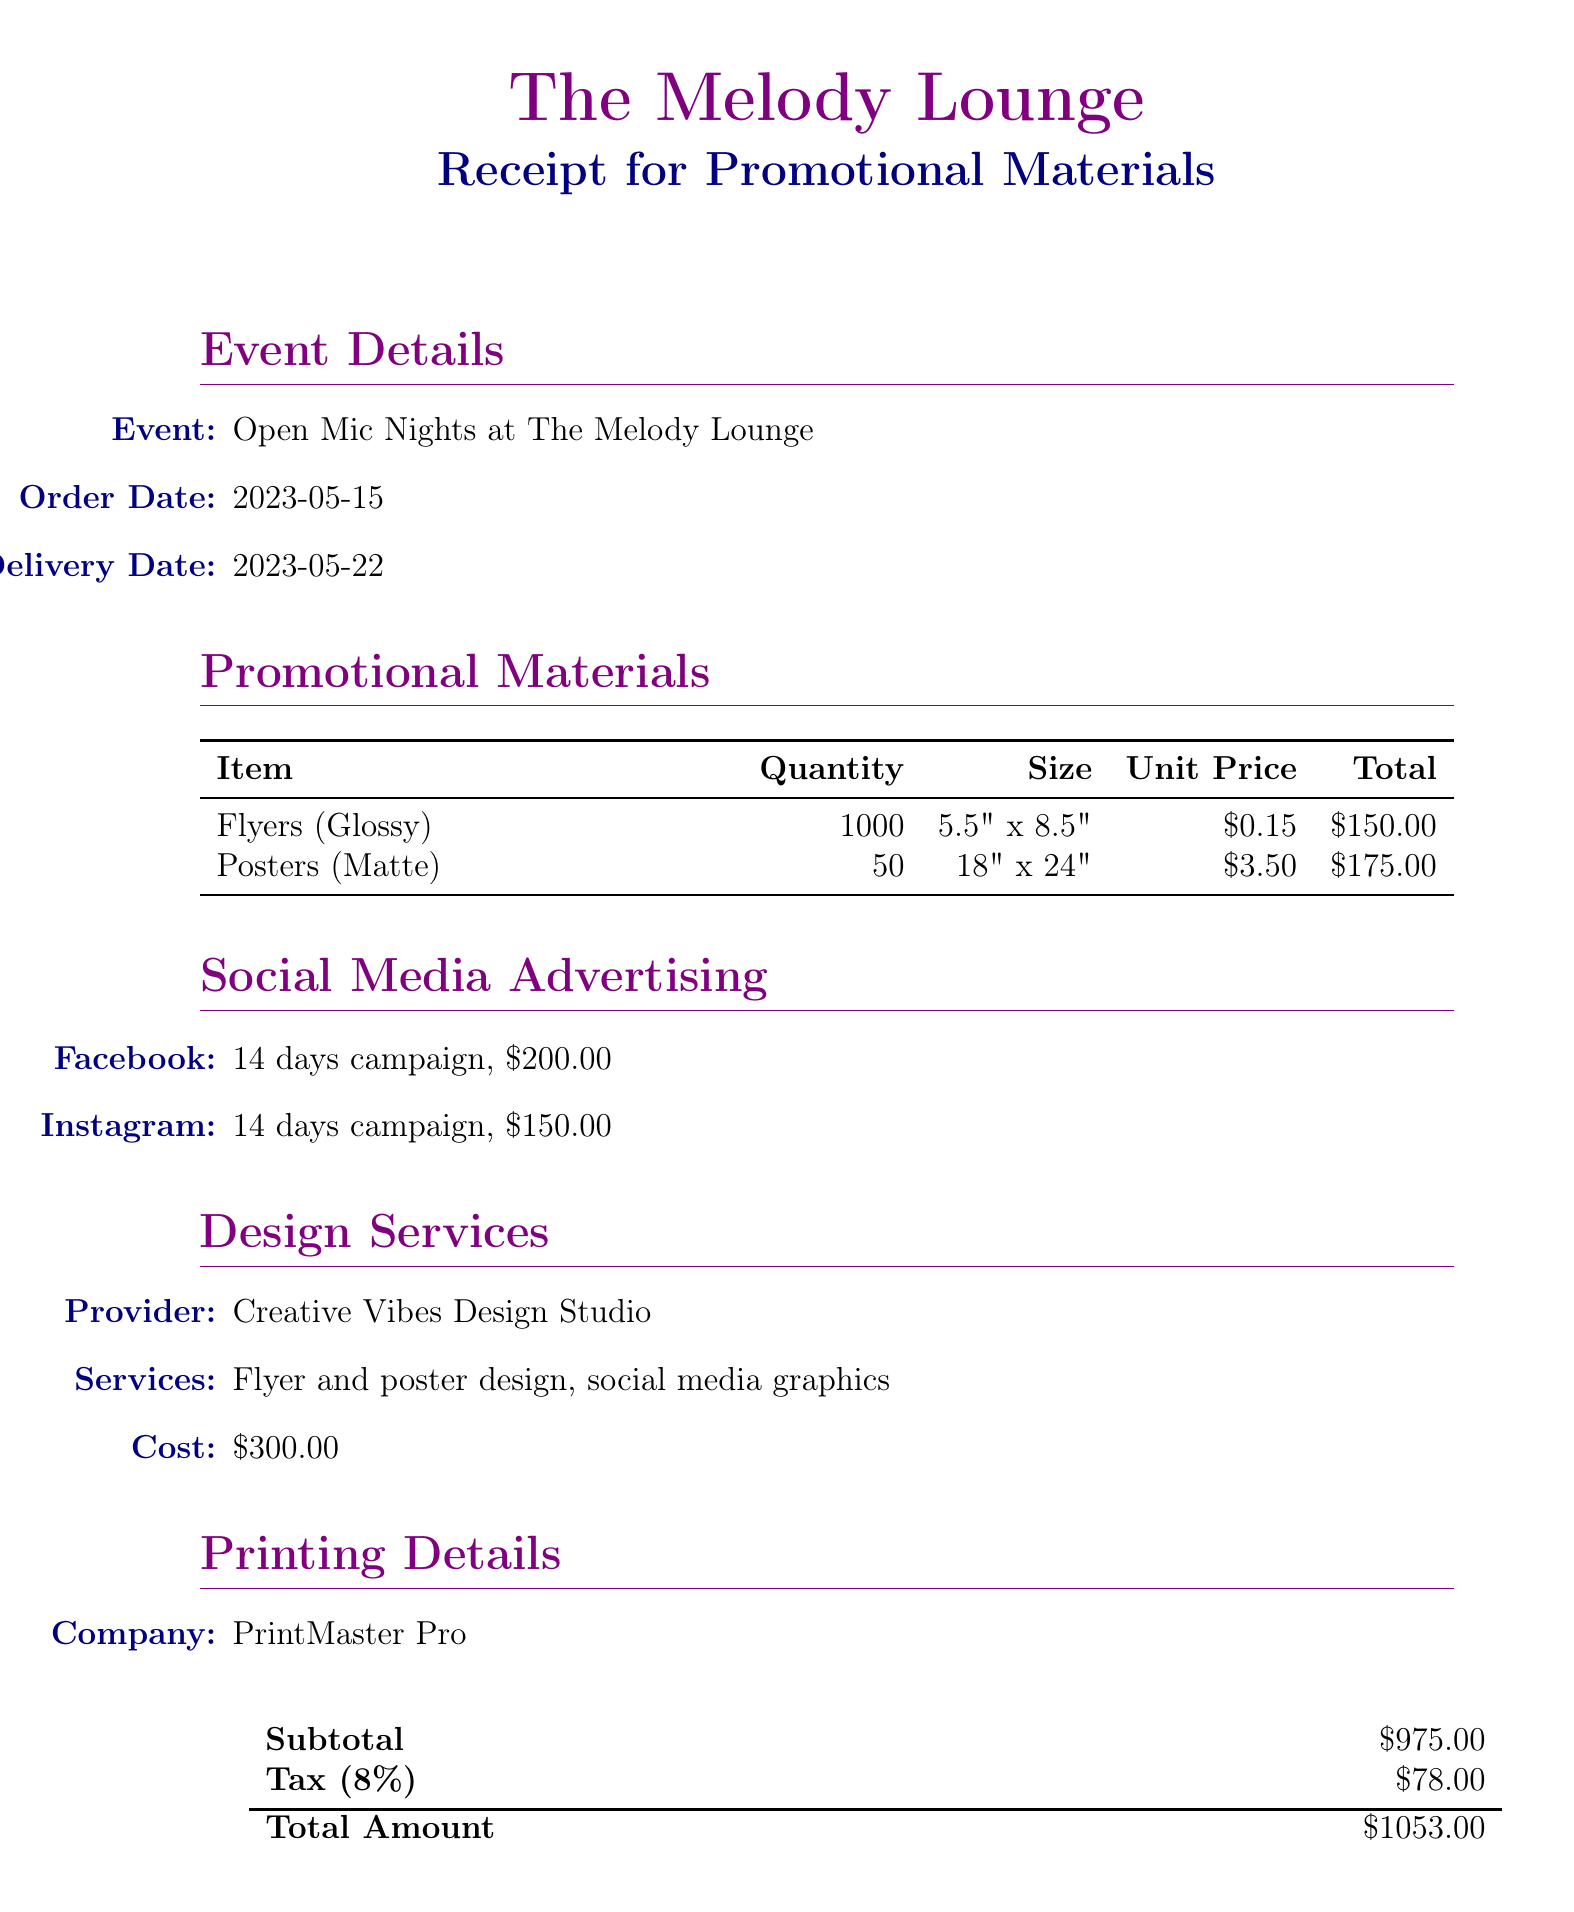What is the venue name? The venue name is listed at the top of the document as the venue hosting the event.
Answer: The Melody Lounge What is the total amount of the receipt? The total amount is clearly indicated in the financial section of the document.
Answer: 1053.00 Who provided the design services? The designer's name and the services they provided are mentioned in the design services section.
Answer: Creative Vibes Design Studio What is the quantity of posters ordered? The quantity is specified in the promotional materials table showing the total number of posters.
Answer: 50 What is the cost of the Facebook advertising campaign? The cost for the Facebook campaign is listed under social media advertising.
Answer: 200.00 What is the delivery date of the promotional materials? The delivery date is provided in the event details at the top of the document.
Answer: 2023-05-22 What is the paper type of the flyers? The paper type is mentioned in the promotional materials section detailing the flyers' specifications.
Answer: Glossy How many days is the Instagram advertising campaign? The duration of the Instagram campaign is found in the details for social media advertising.
Answer: 14 days What additional task is specified regarding the flyers? The additional notes section includes specific instructions for distributing the promotional materials.
Answer: Please distribute flyers to local music stores, coffee shops, and universities 